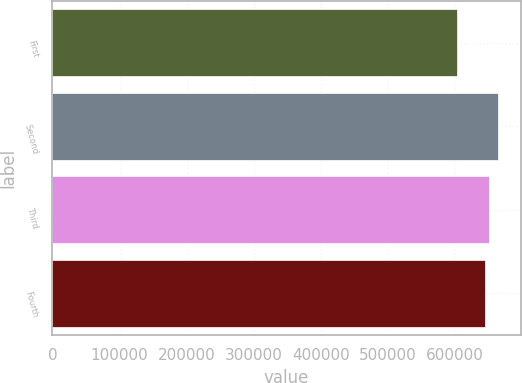Convert chart to OTSL. <chart><loc_0><loc_0><loc_500><loc_500><bar_chart><fcel>First<fcel>Second<fcel>Third<fcel>Fourth<nl><fcel>602828<fcel>665236<fcel>651213<fcel>644972<nl></chart> 